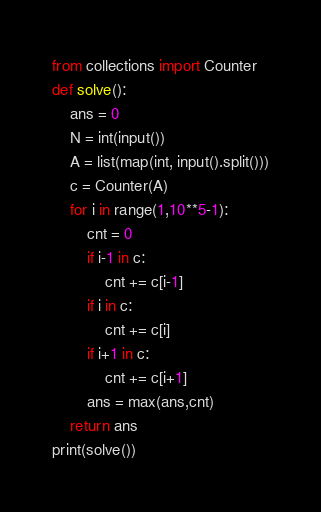Convert code to text. <code><loc_0><loc_0><loc_500><loc_500><_Python_>from collections import Counter
def solve():
    ans = 0
    N = int(input())
    A = list(map(int, input().split()))
    c = Counter(A)
    for i in range(1,10**5-1):
        cnt = 0
        if i-1 in c:
            cnt += c[i-1]
        if i in c:
            cnt += c[i]
        if i+1 in c:
            cnt += c[i+1]
        ans = max(ans,cnt)   
    return ans
print(solve())</code> 